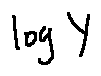Convert formula to latex. <formula><loc_0><loc_0><loc_500><loc_500>\log Y</formula> 